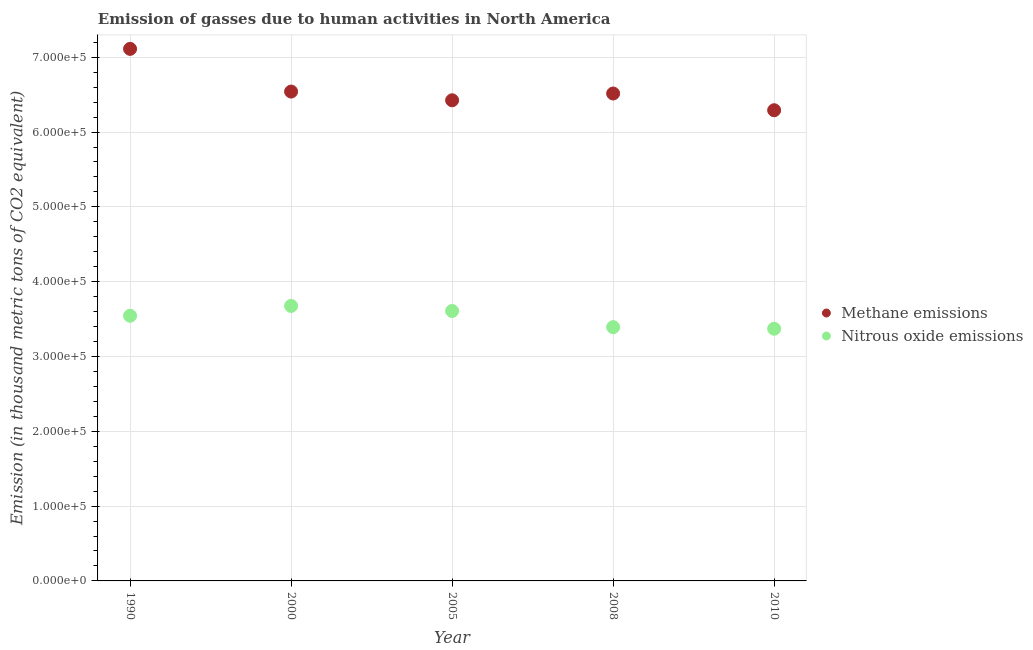How many different coloured dotlines are there?
Ensure brevity in your answer.  2. Is the number of dotlines equal to the number of legend labels?
Ensure brevity in your answer.  Yes. What is the amount of methane emissions in 2000?
Your answer should be compact. 6.54e+05. Across all years, what is the maximum amount of nitrous oxide emissions?
Make the answer very short. 3.68e+05. Across all years, what is the minimum amount of methane emissions?
Offer a very short reply. 6.29e+05. In which year was the amount of nitrous oxide emissions maximum?
Provide a succinct answer. 2000. What is the total amount of methane emissions in the graph?
Provide a succinct answer. 3.29e+06. What is the difference between the amount of nitrous oxide emissions in 2005 and that in 2008?
Your response must be concise. 2.16e+04. What is the difference between the amount of methane emissions in 2000 and the amount of nitrous oxide emissions in 2005?
Ensure brevity in your answer.  2.93e+05. What is the average amount of methane emissions per year?
Make the answer very short. 6.58e+05. In the year 2010, what is the difference between the amount of methane emissions and amount of nitrous oxide emissions?
Provide a succinct answer. 2.92e+05. What is the ratio of the amount of nitrous oxide emissions in 1990 to that in 2008?
Offer a terse response. 1.04. Is the amount of nitrous oxide emissions in 2008 less than that in 2010?
Give a very brief answer. No. What is the difference between the highest and the second highest amount of nitrous oxide emissions?
Your answer should be very brief. 6761.5. What is the difference between the highest and the lowest amount of nitrous oxide emissions?
Ensure brevity in your answer.  3.05e+04. In how many years, is the amount of methane emissions greater than the average amount of methane emissions taken over all years?
Provide a succinct answer. 1. Does the amount of methane emissions monotonically increase over the years?
Your response must be concise. No. Is the amount of methane emissions strictly greater than the amount of nitrous oxide emissions over the years?
Ensure brevity in your answer.  Yes. Is the amount of nitrous oxide emissions strictly less than the amount of methane emissions over the years?
Your response must be concise. Yes. What is the title of the graph?
Make the answer very short. Emission of gasses due to human activities in North America. What is the label or title of the Y-axis?
Offer a very short reply. Emission (in thousand metric tons of CO2 equivalent). What is the Emission (in thousand metric tons of CO2 equivalent) of Methane emissions in 1990?
Offer a very short reply. 7.11e+05. What is the Emission (in thousand metric tons of CO2 equivalent) in Nitrous oxide emissions in 1990?
Your answer should be compact. 3.54e+05. What is the Emission (in thousand metric tons of CO2 equivalent) in Methane emissions in 2000?
Give a very brief answer. 6.54e+05. What is the Emission (in thousand metric tons of CO2 equivalent) of Nitrous oxide emissions in 2000?
Offer a very short reply. 3.68e+05. What is the Emission (in thousand metric tons of CO2 equivalent) of Methane emissions in 2005?
Your answer should be very brief. 6.42e+05. What is the Emission (in thousand metric tons of CO2 equivalent) of Nitrous oxide emissions in 2005?
Offer a very short reply. 3.61e+05. What is the Emission (in thousand metric tons of CO2 equivalent) of Methane emissions in 2008?
Make the answer very short. 6.52e+05. What is the Emission (in thousand metric tons of CO2 equivalent) of Nitrous oxide emissions in 2008?
Provide a short and direct response. 3.39e+05. What is the Emission (in thousand metric tons of CO2 equivalent) in Methane emissions in 2010?
Offer a very short reply. 6.29e+05. What is the Emission (in thousand metric tons of CO2 equivalent) of Nitrous oxide emissions in 2010?
Offer a terse response. 3.37e+05. Across all years, what is the maximum Emission (in thousand metric tons of CO2 equivalent) in Methane emissions?
Give a very brief answer. 7.11e+05. Across all years, what is the maximum Emission (in thousand metric tons of CO2 equivalent) of Nitrous oxide emissions?
Offer a very short reply. 3.68e+05. Across all years, what is the minimum Emission (in thousand metric tons of CO2 equivalent) in Methane emissions?
Your answer should be very brief. 6.29e+05. Across all years, what is the minimum Emission (in thousand metric tons of CO2 equivalent) of Nitrous oxide emissions?
Keep it short and to the point. 3.37e+05. What is the total Emission (in thousand metric tons of CO2 equivalent) in Methane emissions in the graph?
Provide a short and direct response. 3.29e+06. What is the total Emission (in thousand metric tons of CO2 equivalent) of Nitrous oxide emissions in the graph?
Provide a short and direct response. 1.76e+06. What is the difference between the Emission (in thousand metric tons of CO2 equivalent) in Methane emissions in 1990 and that in 2000?
Provide a short and direct response. 5.71e+04. What is the difference between the Emission (in thousand metric tons of CO2 equivalent) in Nitrous oxide emissions in 1990 and that in 2000?
Give a very brief answer. -1.31e+04. What is the difference between the Emission (in thousand metric tons of CO2 equivalent) of Methane emissions in 1990 and that in 2005?
Ensure brevity in your answer.  6.87e+04. What is the difference between the Emission (in thousand metric tons of CO2 equivalent) of Nitrous oxide emissions in 1990 and that in 2005?
Your answer should be compact. -6378.7. What is the difference between the Emission (in thousand metric tons of CO2 equivalent) in Methane emissions in 1990 and that in 2008?
Offer a very short reply. 5.97e+04. What is the difference between the Emission (in thousand metric tons of CO2 equivalent) in Nitrous oxide emissions in 1990 and that in 2008?
Ensure brevity in your answer.  1.52e+04. What is the difference between the Emission (in thousand metric tons of CO2 equivalent) of Methane emissions in 1990 and that in 2010?
Your response must be concise. 8.20e+04. What is the difference between the Emission (in thousand metric tons of CO2 equivalent) of Nitrous oxide emissions in 1990 and that in 2010?
Provide a short and direct response. 1.74e+04. What is the difference between the Emission (in thousand metric tons of CO2 equivalent) of Methane emissions in 2000 and that in 2005?
Your answer should be very brief. 1.17e+04. What is the difference between the Emission (in thousand metric tons of CO2 equivalent) of Nitrous oxide emissions in 2000 and that in 2005?
Provide a succinct answer. 6761.5. What is the difference between the Emission (in thousand metric tons of CO2 equivalent) in Methane emissions in 2000 and that in 2008?
Ensure brevity in your answer.  2610. What is the difference between the Emission (in thousand metric tons of CO2 equivalent) of Nitrous oxide emissions in 2000 and that in 2008?
Provide a succinct answer. 2.84e+04. What is the difference between the Emission (in thousand metric tons of CO2 equivalent) in Methane emissions in 2000 and that in 2010?
Provide a short and direct response. 2.50e+04. What is the difference between the Emission (in thousand metric tons of CO2 equivalent) in Nitrous oxide emissions in 2000 and that in 2010?
Your response must be concise. 3.05e+04. What is the difference between the Emission (in thousand metric tons of CO2 equivalent) in Methane emissions in 2005 and that in 2008?
Your answer should be very brief. -9061.6. What is the difference between the Emission (in thousand metric tons of CO2 equivalent) in Nitrous oxide emissions in 2005 and that in 2008?
Your answer should be compact. 2.16e+04. What is the difference between the Emission (in thousand metric tons of CO2 equivalent) in Methane emissions in 2005 and that in 2010?
Offer a terse response. 1.33e+04. What is the difference between the Emission (in thousand metric tons of CO2 equivalent) of Nitrous oxide emissions in 2005 and that in 2010?
Provide a succinct answer. 2.37e+04. What is the difference between the Emission (in thousand metric tons of CO2 equivalent) of Methane emissions in 2008 and that in 2010?
Provide a short and direct response. 2.23e+04. What is the difference between the Emission (in thousand metric tons of CO2 equivalent) in Nitrous oxide emissions in 2008 and that in 2010?
Ensure brevity in your answer.  2132.3. What is the difference between the Emission (in thousand metric tons of CO2 equivalent) of Methane emissions in 1990 and the Emission (in thousand metric tons of CO2 equivalent) of Nitrous oxide emissions in 2000?
Make the answer very short. 3.44e+05. What is the difference between the Emission (in thousand metric tons of CO2 equivalent) of Methane emissions in 1990 and the Emission (in thousand metric tons of CO2 equivalent) of Nitrous oxide emissions in 2005?
Ensure brevity in your answer.  3.50e+05. What is the difference between the Emission (in thousand metric tons of CO2 equivalent) of Methane emissions in 1990 and the Emission (in thousand metric tons of CO2 equivalent) of Nitrous oxide emissions in 2008?
Offer a terse response. 3.72e+05. What is the difference between the Emission (in thousand metric tons of CO2 equivalent) of Methane emissions in 1990 and the Emission (in thousand metric tons of CO2 equivalent) of Nitrous oxide emissions in 2010?
Ensure brevity in your answer.  3.74e+05. What is the difference between the Emission (in thousand metric tons of CO2 equivalent) in Methane emissions in 2000 and the Emission (in thousand metric tons of CO2 equivalent) in Nitrous oxide emissions in 2005?
Provide a succinct answer. 2.93e+05. What is the difference between the Emission (in thousand metric tons of CO2 equivalent) in Methane emissions in 2000 and the Emission (in thousand metric tons of CO2 equivalent) in Nitrous oxide emissions in 2008?
Provide a short and direct response. 3.15e+05. What is the difference between the Emission (in thousand metric tons of CO2 equivalent) in Methane emissions in 2000 and the Emission (in thousand metric tons of CO2 equivalent) in Nitrous oxide emissions in 2010?
Give a very brief answer. 3.17e+05. What is the difference between the Emission (in thousand metric tons of CO2 equivalent) of Methane emissions in 2005 and the Emission (in thousand metric tons of CO2 equivalent) of Nitrous oxide emissions in 2008?
Make the answer very short. 3.03e+05. What is the difference between the Emission (in thousand metric tons of CO2 equivalent) of Methane emissions in 2005 and the Emission (in thousand metric tons of CO2 equivalent) of Nitrous oxide emissions in 2010?
Provide a short and direct response. 3.05e+05. What is the difference between the Emission (in thousand metric tons of CO2 equivalent) in Methane emissions in 2008 and the Emission (in thousand metric tons of CO2 equivalent) in Nitrous oxide emissions in 2010?
Provide a short and direct response. 3.14e+05. What is the average Emission (in thousand metric tons of CO2 equivalent) of Methane emissions per year?
Provide a succinct answer. 6.58e+05. What is the average Emission (in thousand metric tons of CO2 equivalent) in Nitrous oxide emissions per year?
Provide a succinct answer. 3.52e+05. In the year 1990, what is the difference between the Emission (in thousand metric tons of CO2 equivalent) of Methane emissions and Emission (in thousand metric tons of CO2 equivalent) of Nitrous oxide emissions?
Your answer should be very brief. 3.57e+05. In the year 2000, what is the difference between the Emission (in thousand metric tons of CO2 equivalent) in Methane emissions and Emission (in thousand metric tons of CO2 equivalent) in Nitrous oxide emissions?
Provide a succinct answer. 2.87e+05. In the year 2005, what is the difference between the Emission (in thousand metric tons of CO2 equivalent) of Methane emissions and Emission (in thousand metric tons of CO2 equivalent) of Nitrous oxide emissions?
Offer a very short reply. 2.82e+05. In the year 2008, what is the difference between the Emission (in thousand metric tons of CO2 equivalent) of Methane emissions and Emission (in thousand metric tons of CO2 equivalent) of Nitrous oxide emissions?
Your answer should be compact. 3.12e+05. In the year 2010, what is the difference between the Emission (in thousand metric tons of CO2 equivalent) in Methane emissions and Emission (in thousand metric tons of CO2 equivalent) in Nitrous oxide emissions?
Make the answer very short. 2.92e+05. What is the ratio of the Emission (in thousand metric tons of CO2 equivalent) in Methane emissions in 1990 to that in 2000?
Make the answer very short. 1.09. What is the ratio of the Emission (in thousand metric tons of CO2 equivalent) of Nitrous oxide emissions in 1990 to that in 2000?
Provide a short and direct response. 0.96. What is the ratio of the Emission (in thousand metric tons of CO2 equivalent) of Methane emissions in 1990 to that in 2005?
Keep it short and to the point. 1.11. What is the ratio of the Emission (in thousand metric tons of CO2 equivalent) in Nitrous oxide emissions in 1990 to that in 2005?
Offer a very short reply. 0.98. What is the ratio of the Emission (in thousand metric tons of CO2 equivalent) in Methane emissions in 1990 to that in 2008?
Ensure brevity in your answer.  1.09. What is the ratio of the Emission (in thousand metric tons of CO2 equivalent) in Nitrous oxide emissions in 1990 to that in 2008?
Provide a short and direct response. 1.04. What is the ratio of the Emission (in thousand metric tons of CO2 equivalent) of Methane emissions in 1990 to that in 2010?
Keep it short and to the point. 1.13. What is the ratio of the Emission (in thousand metric tons of CO2 equivalent) of Nitrous oxide emissions in 1990 to that in 2010?
Provide a short and direct response. 1.05. What is the ratio of the Emission (in thousand metric tons of CO2 equivalent) of Methane emissions in 2000 to that in 2005?
Provide a succinct answer. 1.02. What is the ratio of the Emission (in thousand metric tons of CO2 equivalent) in Nitrous oxide emissions in 2000 to that in 2005?
Offer a terse response. 1.02. What is the ratio of the Emission (in thousand metric tons of CO2 equivalent) of Nitrous oxide emissions in 2000 to that in 2008?
Your response must be concise. 1.08. What is the ratio of the Emission (in thousand metric tons of CO2 equivalent) of Methane emissions in 2000 to that in 2010?
Make the answer very short. 1.04. What is the ratio of the Emission (in thousand metric tons of CO2 equivalent) of Nitrous oxide emissions in 2000 to that in 2010?
Offer a very short reply. 1.09. What is the ratio of the Emission (in thousand metric tons of CO2 equivalent) of Methane emissions in 2005 to that in 2008?
Ensure brevity in your answer.  0.99. What is the ratio of the Emission (in thousand metric tons of CO2 equivalent) of Nitrous oxide emissions in 2005 to that in 2008?
Your response must be concise. 1.06. What is the ratio of the Emission (in thousand metric tons of CO2 equivalent) in Methane emissions in 2005 to that in 2010?
Offer a very short reply. 1.02. What is the ratio of the Emission (in thousand metric tons of CO2 equivalent) of Nitrous oxide emissions in 2005 to that in 2010?
Your answer should be very brief. 1.07. What is the ratio of the Emission (in thousand metric tons of CO2 equivalent) of Methane emissions in 2008 to that in 2010?
Offer a terse response. 1.04. What is the difference between the highest and the second highest Emission (in thousand metric tons of CO2 equivalent) in Methane emissions?
Provide a short and direct response. 5.71e+04. What is the difference between the highest and the second highest Emission (in thousand metric tons of CO2 equivalent) of Nitrous oxide emissions?
Give a very brief answer. 6761.5. What is the difference between the highest and the lowest Emission (in thousand metric tons of CO2 equivalent) of Methane emissions?
Ensure brevity in your answer.  8.20e+04. What is the difference between the highest and the lowest Emission (in thousand metric tons of CO2 equivalent) of Nitrous oxide emissions?
Offer a very short reply. 3.05e+04. 